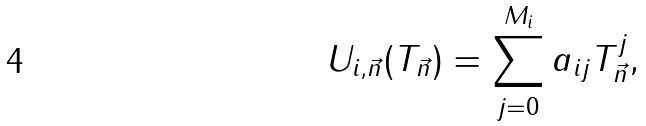<formula> <loc_0><loc_0><loc_500><loc_500>U _ { i , \vec { n } } ( T _ { \vec { n } } ) = \sum _ { j = 0 } ^ { M _ { i } } a _ { i j } T ^ { j } _ { \vec { n } } ,</formula> 